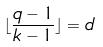Convert formula to latex. <formula><loc_0><loc_0><loc_500><loc_500>\lfloor \frac { q - 1 } { k - 1 } \rfloor = d</formula> 